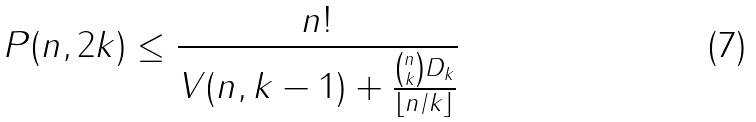Convert formula to latex. <formula><loc_0><loc_0><loc_500><loc_500>P ( n , 2 k ) \leq \frac { n ! } { V ( n , k - 1 ) + \frac { { n \choose k } D _ { k } } { \lfloor n / k \rfloor } }</formula> 